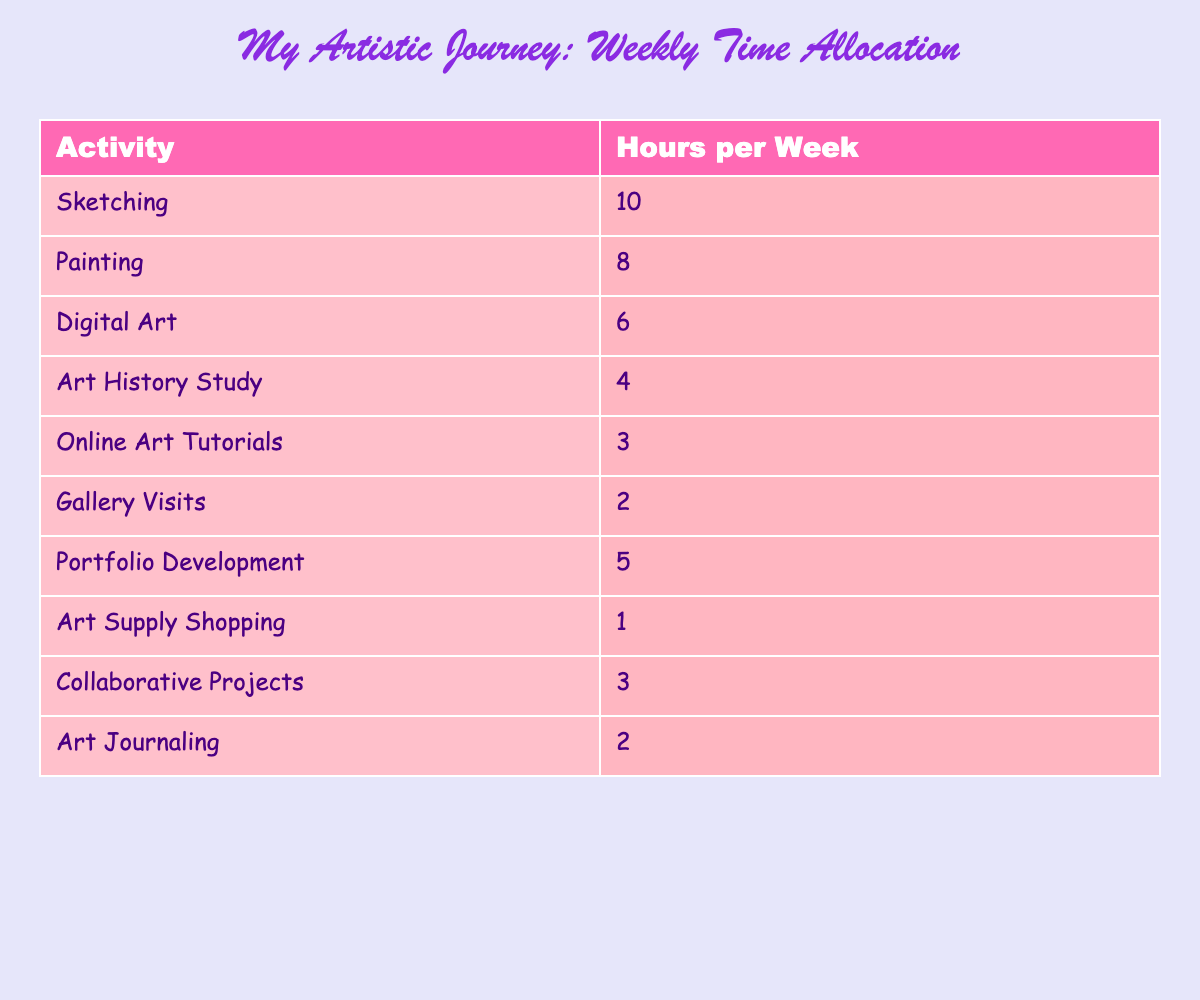What activity takes the least amount of time per week? The table shows the hours allocated per week for various art activities. By scanning through the hours listed for each activity, we can see that "Art Supply Shopping" is listed with only 1 hour.
Answer: Art Supply Shopping How many hours per week are spent on digital art and online art tutorials combined? To find the combined hours for "Digital Art" and "Online Art Tutorials," we add the hours for each activity: Digital Art (6 hours) + Online Art Tutorials (3 hours) = 9 hours total.
Answer: 9 hours Is the time allocated for Portfolio Development greater than the time for Gallery Visits? By looking at the hours allocated in the table, "Portfolio Development" has 5 hours while "Gallery Visits" has only 2 hours. Since 5 is greater than 2, the statement is true.
Answer: Yes What is the total number of hours per week spent on art history study and gallery visits? First, identify the hours for each activity: Art History Study has 4 hours and Gallery Visits has 2 hours. Adding these gives us: 4 hours + 2 hours = 6 hours total.
Answer: 6 hours Which two activities have the most hours allocated? The two activities with the highest hours allocated can be identified by looking at the numbers. The highest is "Sketching" with 10 hours, followed by "Painting" with 8 hours.
Answer: Sketching and Painting What is the average time spent on the eight activities listed? First, we need to sum the total hours allocated for all activities. Adding them gives:
10 + 8 + 6 + 4 + 3 + 2 + 5 + 1 + 3 + 2 = 44 hours. There are 10 activities, so to find the average, we divide the total hours by the number of activities: 44 hours ÷ 10 activities = 4.4 hours.
Answer: 4.4 hours Are more hours spent on collaborative projects than on art history study? From the table, "Collaborative Projects" is allocated 3 hours while "Art History Study" is allocated 4 hours. Since 3 is not greater than 4, the statement is false.
Answer: No What percentage of the total weekly hours is spent on sketching? First, we previously found that the total hours for all activities is 44 hours. Sketching has 10 hours, so the percentage can be calculated as (10 hours / 44 hours) × 100 = 22.73%.
Answer: 22.73% 